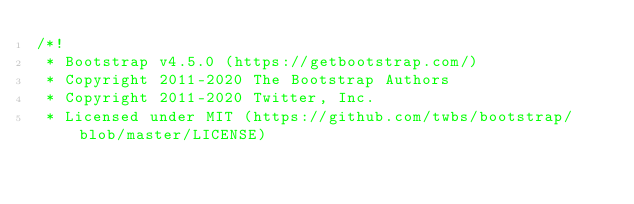<code> <loc_0><loc_0><loc_500><loc_500><_CSS_>/*!
 * Bootstrap v4.5.0 (https://getbootstrap.com/)
 * Copyright 2011-2020 The Bootstrap Authors
 * Copyright 2011-2020 Twitter, Inc.
 * Licensed under MIT (https://github.com/twbs/bootstrap/blob/master/LICENSE)</code> 